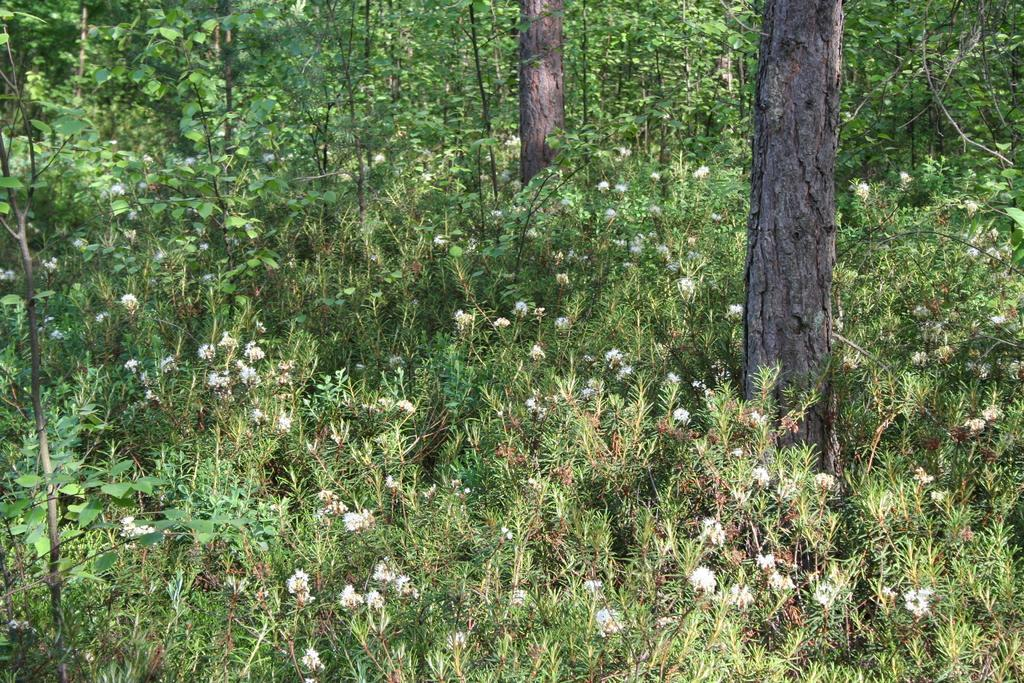What type of vegetation can be seen in the image? There are plants, flowers, and trees in the image. Can you describe the specific types of plants in the image? The image features flowers and trees, but the specific types of plants cannot be determined from the image alone. What is the primary focus of the image? The primary focus of the image is the vegetation, including plants, flowers, and trees. What type of memory is stored in the image? There is no memory present in the image; it features plants, flowers, and trees. Can you tell me how much zinc is present in the image? There is no zinc present in the image; it features plants, flowers, and trees. 